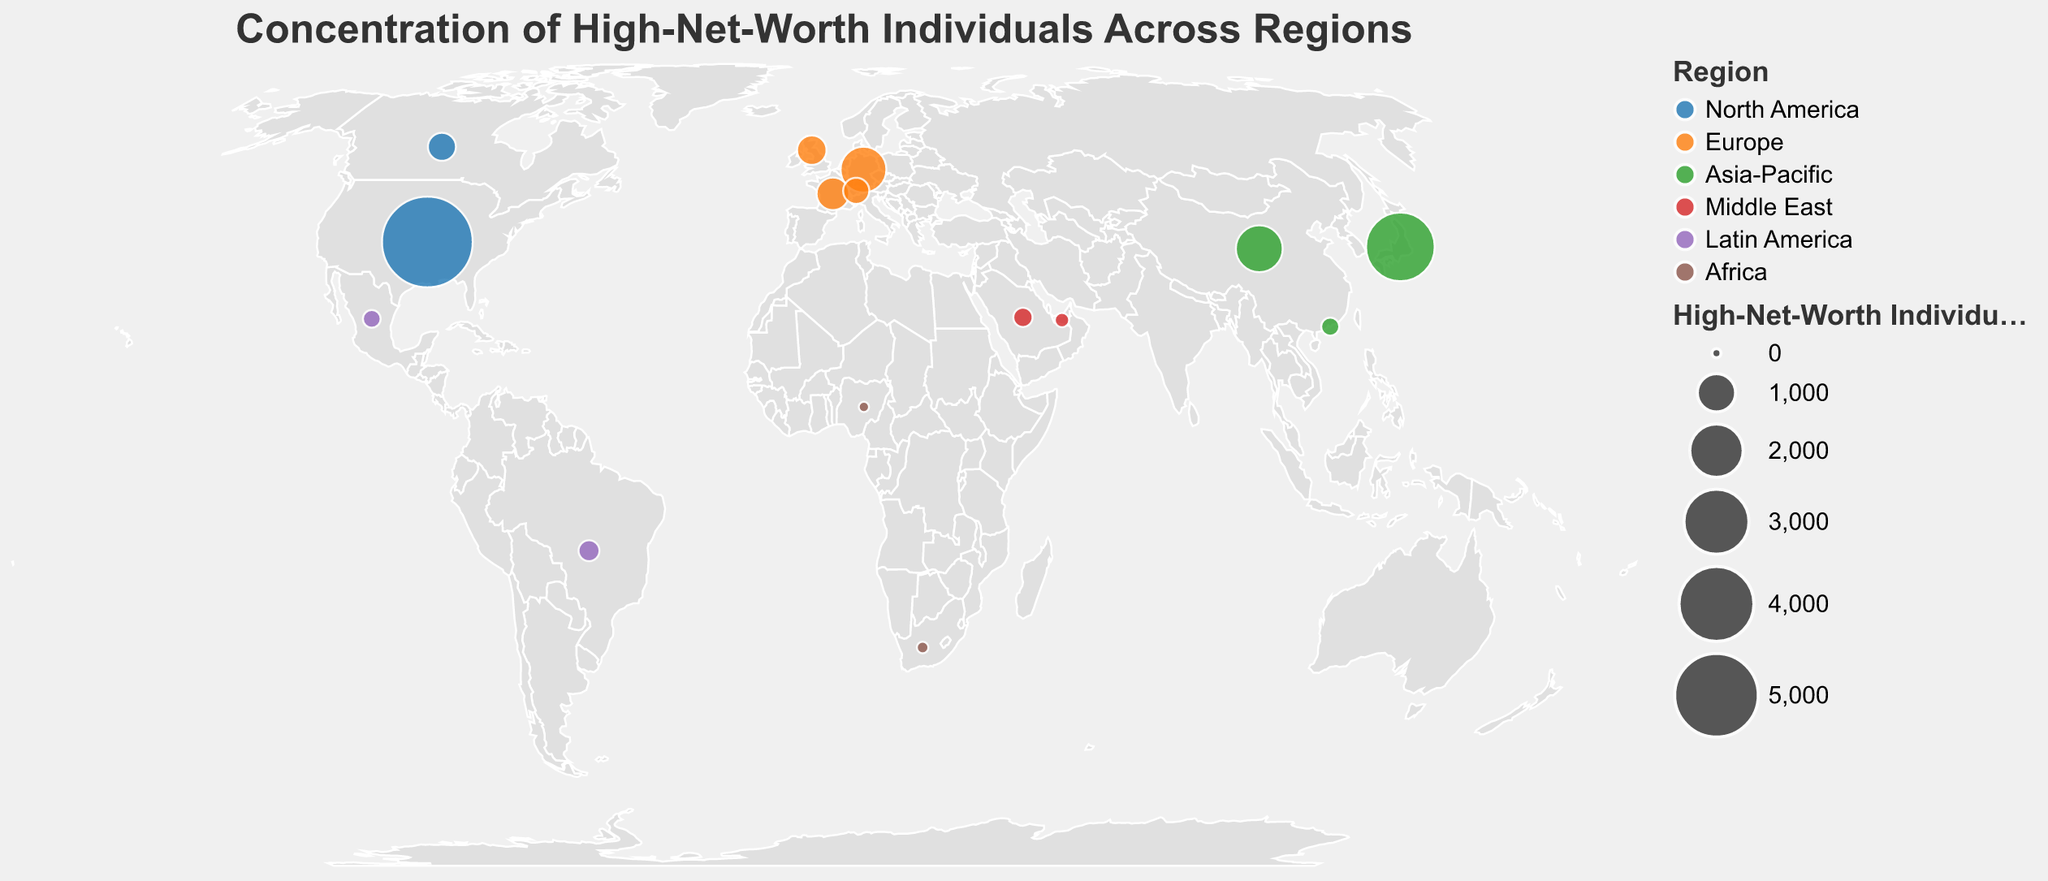What is the title of the figure? The title is prominently displayed at the top of the figure. It summarizes the overarching topic of the plot.
Answer: Concentration of High-Net-Worth Individuals Across Regions How many regions are represented in the plot? Each region is indicated with a distinct color on the plot. By counting the different colors and checking the legend, one can determine the number of regions.
Answer: 6 Which country has the highest number of high-net-worth individuals? The largest circle on the plot represents the highest value. By checking the tooltip or legend when the largest circle is hovered over, the country can be identified.
Answer: United States What is the combined number of high-net-worth individuals in the Asia-Pacific region? Sum the values of high-net-worth individuals for China, Japan, and Hong Kong from the data. The tooltip or the visible numerical estimates can be used for reference.
Answer: 5080 Which region in the plot has the least concentration of high-net-worth individuals? The smallest circle or circles, indicated in the legend or by the tooltip, represent the least concentration. Check for the region to which this data point belongs.
Answer: Africa Compare the number of high-net-worth individuals in Germany and in China. Which is higher? Look for the circles representing Germany and China. By using the tooltip for precise numbers or visual estimation, compare the values directly.
Answer: China Which countries in the Middle East are shown in the plot? By looking at the legend for the Middle East color, and then identifying the corresponding circles on the plot, the countries can be found.
Answer: United Arab Emirates, Saudi Arabia What is the difference in the number of high-net-worth individuals between France and Canada? Identify the circles for France and Canada, use the tooltip to get the precise values, and then calculate the difference.
Answer: 202 How does the concentration of high-net-worth individuals in the United Kingdom compare to that in Switzerland? Use the tooltip to check the values for both the United Kingdom and Switzerland, then compare these values.
Answer: United Kingdom has more Which country in Latin America has a higher count of high-net-worth individuals, Brazil or Mexico? Identify the circles for Brazil and Mexico using the legend or visual inspection, then use the tooltip to get the values and compare them.
Answer: Brazil 